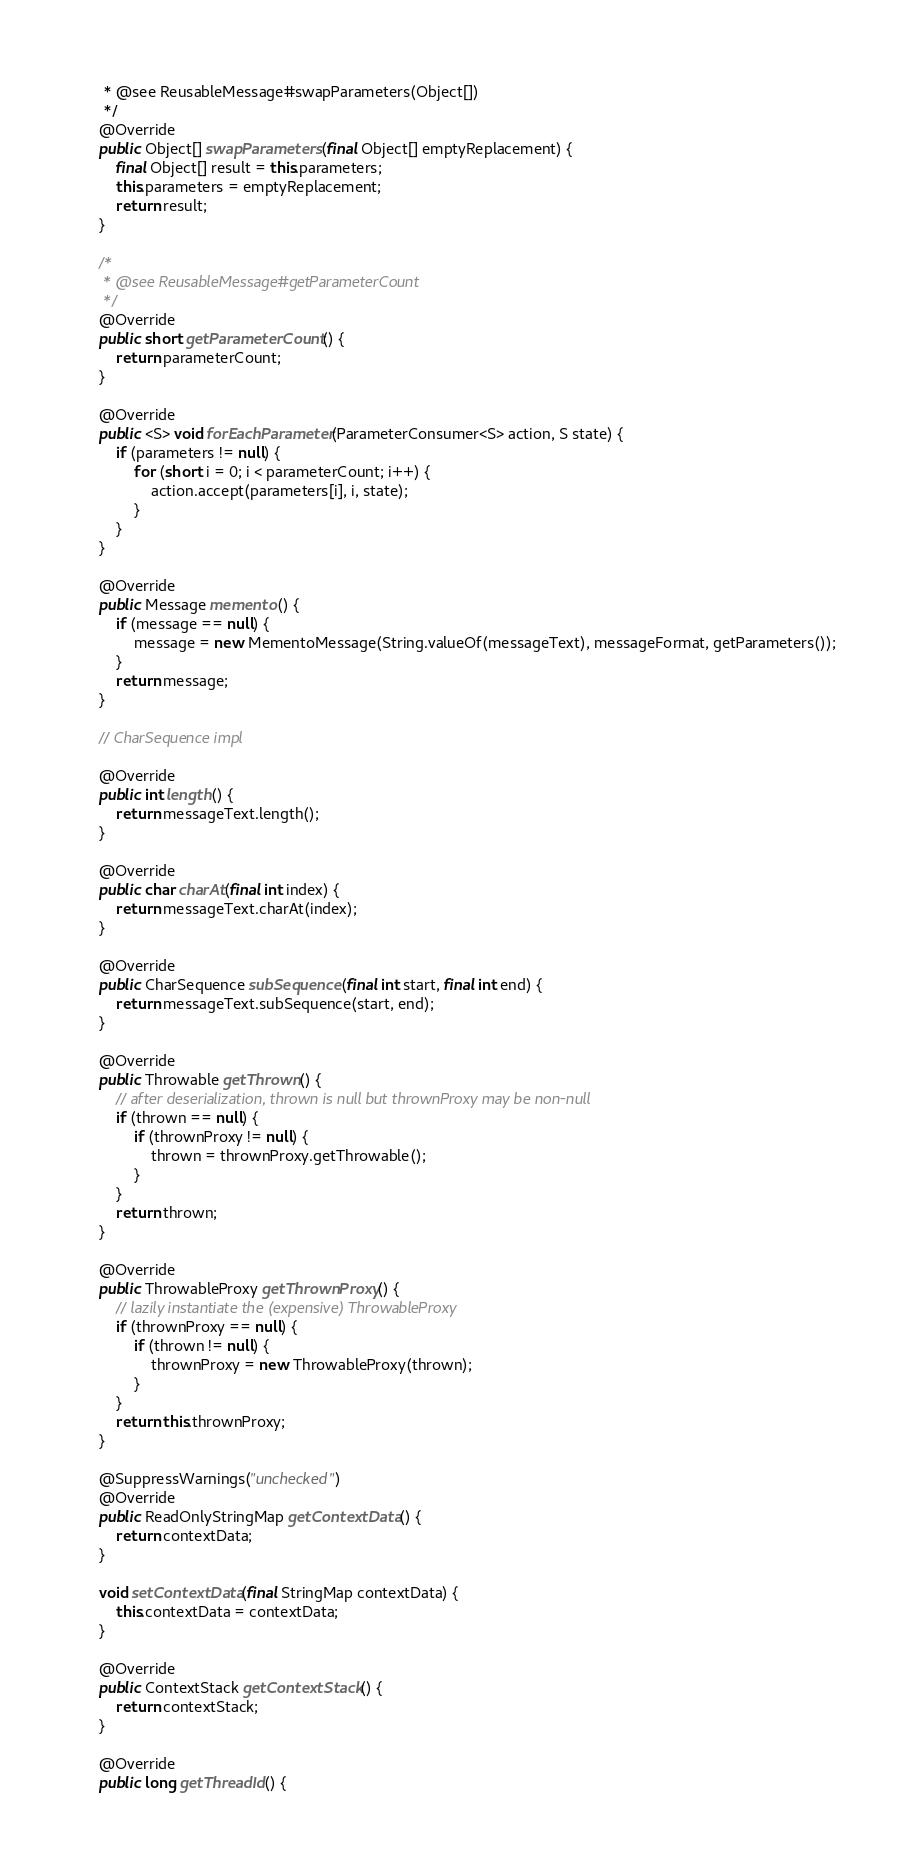<code> <loc_0><loc_0><loc_500><loc_500><_Java_>     * @see ReusableMessage#swapParameters(Object[])
     */
    @Override
    public Object[] swapParameters(final Object[] emptyReplacement) {
        final Object[] result = this.parameters;
        this.parameters = emptyReplacement;
        return result;
    }

    /*
     * @see ReusableMessage#getParameterCount
     */
    @Override
    public short getParameterCount() {
        return parameterCount;
    }

    @Override
    public <S> void forEachParameter(ParameterConsumer<S> action, S state) {
        if (parameters != null) {
            for (short i = 0; i < parameterCount; i++) {
                action.accept(parameters[i], i, state);
            }
        }
    }

    @Override
    public Message memento() {
        if (message == null) {
            message = new MementoMessage(String.valueOf(messageText), messageFormat, getParameters());
        }
        return message;
    }

    // CharSequence impl

    @Override
    public int length() {
        return messageText.length();
    }

    @Override
    public char charAt(final int index) {
        return messageText.charAt(index);
    }

    @Override
    public CharSequence subSequence(final int start, final int end) {
        return messageText.subSequence(start, end);
    }

    @Override
    public Throwable getThrown() {
        // after deserialization, thrown is null but thrownProxy may be non-null
        if (thrown == null) {
            if (thrownProxy != null) {
                thrown = thrownProxy.getThrowable();
            }
        }
        return thrown;
    }

    @Override
    public ThrowableProxy getThrownProxy() {
        // lazily instantiate the (expensive) ThrowableProxy
        if (thrownProxy == null) {
            if (thrown != null) {
                thrownProxy = new ThrowableProxy(thrown);
            }
        }
        return this.thrownProxy;
    }

    @SuppressWarnings("unchecked")
    @Override
    public ReadOnlyStringMap getContextData() {
        return contextData;
    }

    void setContextData(final StringMap contextData) {
        this.contextData = contextData;
    }

    @Override
    public ContextStack getContextStack() {
        return contextStack;
    }

    @Override
    public long getThreadId() {</code> 